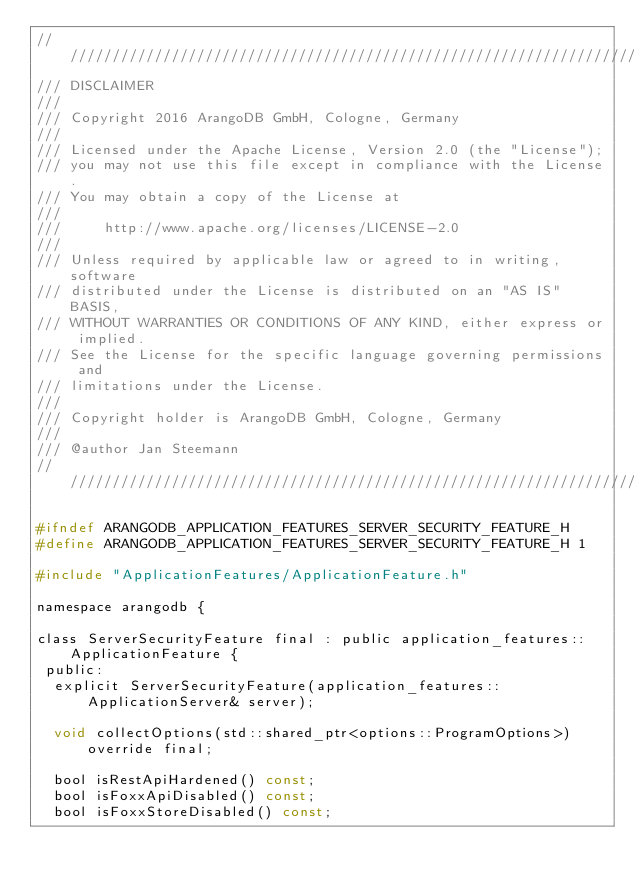<code> <loc_0><loc_0><loc_500><loc_500><_C_>////////////////////////////////////////////////////////////////////////////////
/// DISCLAIMER
///
/// Copyright 2016 ArangoDB GmbH, Cologne, Germany
///
/// Licensed under the Apache License, Version 2.0 (the "License");
/// you may not use this file except in compliance with the License.
/// You may obtain a copy of the License at
///
///     http://www.apache.org/licenses/LICENSE-2.0
///
/// Unless required by applicable law or agreed to in writing, software
/// distributed under the License is distributed on an "AS IS" BASIS,
/// WITHOUT WARRANTIES OR CONDITIONS OF ANY KIND, either express or implied.
/// See the License for the specific language governing permissions and
/// limitations under the License.
///
/// Copyright holder is ArangoDB GmbH, Cologne, Germany
///
/// @author Jan Steemann
////////////////////////////////////////////////////////////////////////////////

#ifndef ARANGODB_APPLICATION_FEATURES_SERVER_SECURITY_FEATURE_H
#define ARANGODB_APPLICATION_FEATURES_SERVER_SECURITY_FEATURE_H 1

#include "ApplicationFeatures/ApplicationFeature.h"

namespace arangodb {

class ServerSecurityFeature final : public application_features::ApplicationFeature {
 public:
  explicit ServerSecurityFeature(application_features::ApplicationServer& server);

  void collectOptions(std::shared_ptr<options::ProgramOptions>) override final;

  bool isRestApiHardened() const;
  bool isFoxxApiDisabled() const;
  bool isFoxxStoreDisabled() const;</code> 